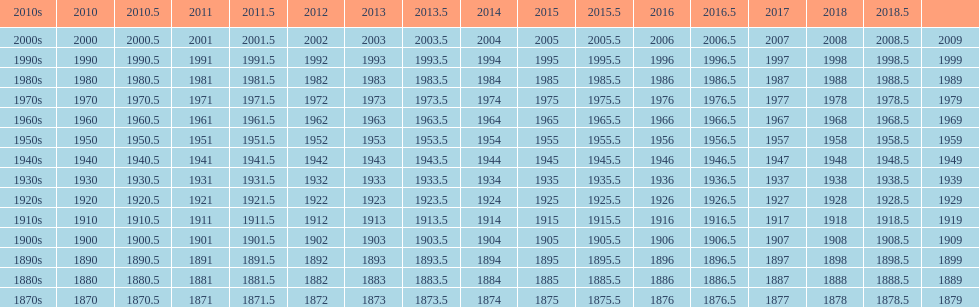Which decade is the only one to have fewer years in its row than the others? 2010s. 